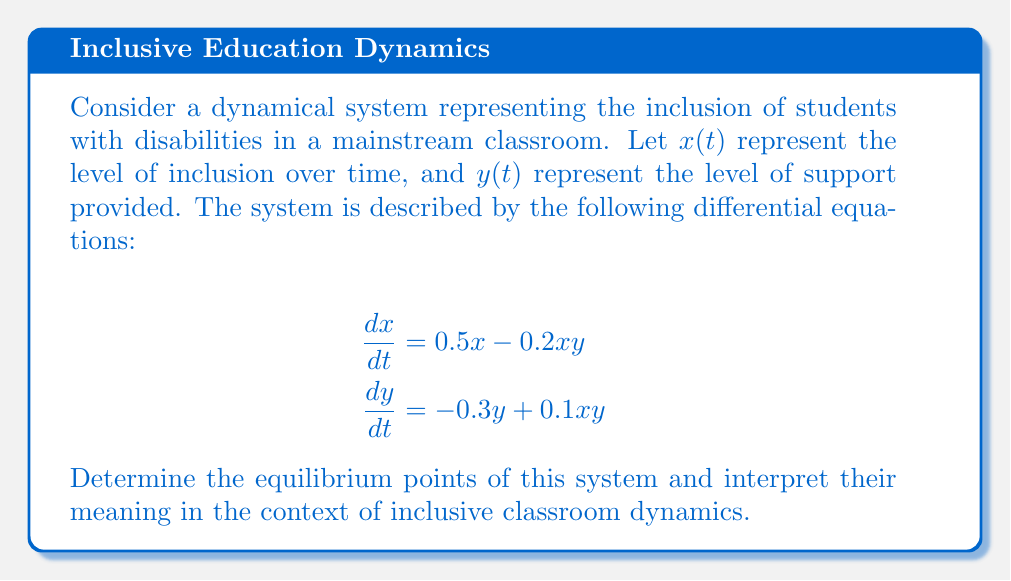Could you help me with this problem? To find the equilibrium points, we set both equations equal to zero and solve for x and y:

1) Set $\frac{dx}{dt} = 0$ and $\frac{dy}{dt} = 0$:

   $0.5x - 0.2xy = 0$
   $-0.3y + 0.1xy = 0$

2) From the first equation:
   $0.5x - 0.2xy = 0$
   $x(0.5 - 0.2y) = 0$
   
   This gives us two possibilities:
   a) $x = 0$, or
   b) $0.5 - 0.2y = 0$, which means $y = 2.5$

3) From the second equation:
   $-0.3y + 0.1xy = 0$
   $y(-0.3 + 0.1x) = 0$
   
   This gives us two possibilities:
   a) $y = 0$, or
   b) $-0.3 + 0.1x = 0$, which means $x = 3$

4) Combining these results, we get three equilibrium points:
   (0, 0), (3, 2.5), and (0, 2.5)

5) Interpretation:
   - (0, 0): No inclusion and no support - represents a completely segregated classroom.
   - (3, 2.5): Balanced inclusion and support - represents an ideal inclusive classroom.
   - (0, 2.5): Support without inclusion - represents a scenario where resources are allocated but not effectively utilized for inclusion.
Answer: The equilibrium points are (0, 0), (3, 2.5), and (0, 2.5). 